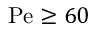Convert formula to latex. <formula><loc_0><loc_0><loc_500><loc_500>P e \geq 6 0</formula> 